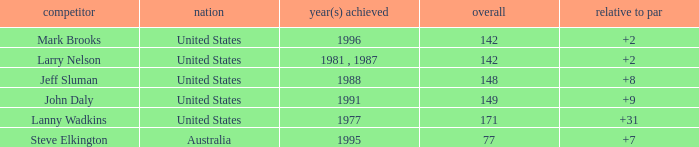Could you help me parse every detail presented in this table? {'header': ['competitor', 'nation', 'year(s) achieved', 'overall', 'relative to par'], 'rows': [['Mark Brooks', 'United States', '1996', '142', '+2'], ['Larry Nelson', 'United States', '1981 , 1987', '142', '+2'], ['Jeff Sluman', 'United States', '1988', '148', '+8'], ['John Daly', 'United States', '1991', '149', '+9'], ['Lanny Wadkins', 'United States', '1977', '171', '+31'], ['Steve Elkington', 'Australia', '1995', '77', '+7']]} Name the To par that has a Year(s) won of 1988 and a Total smaller than 148? None. 